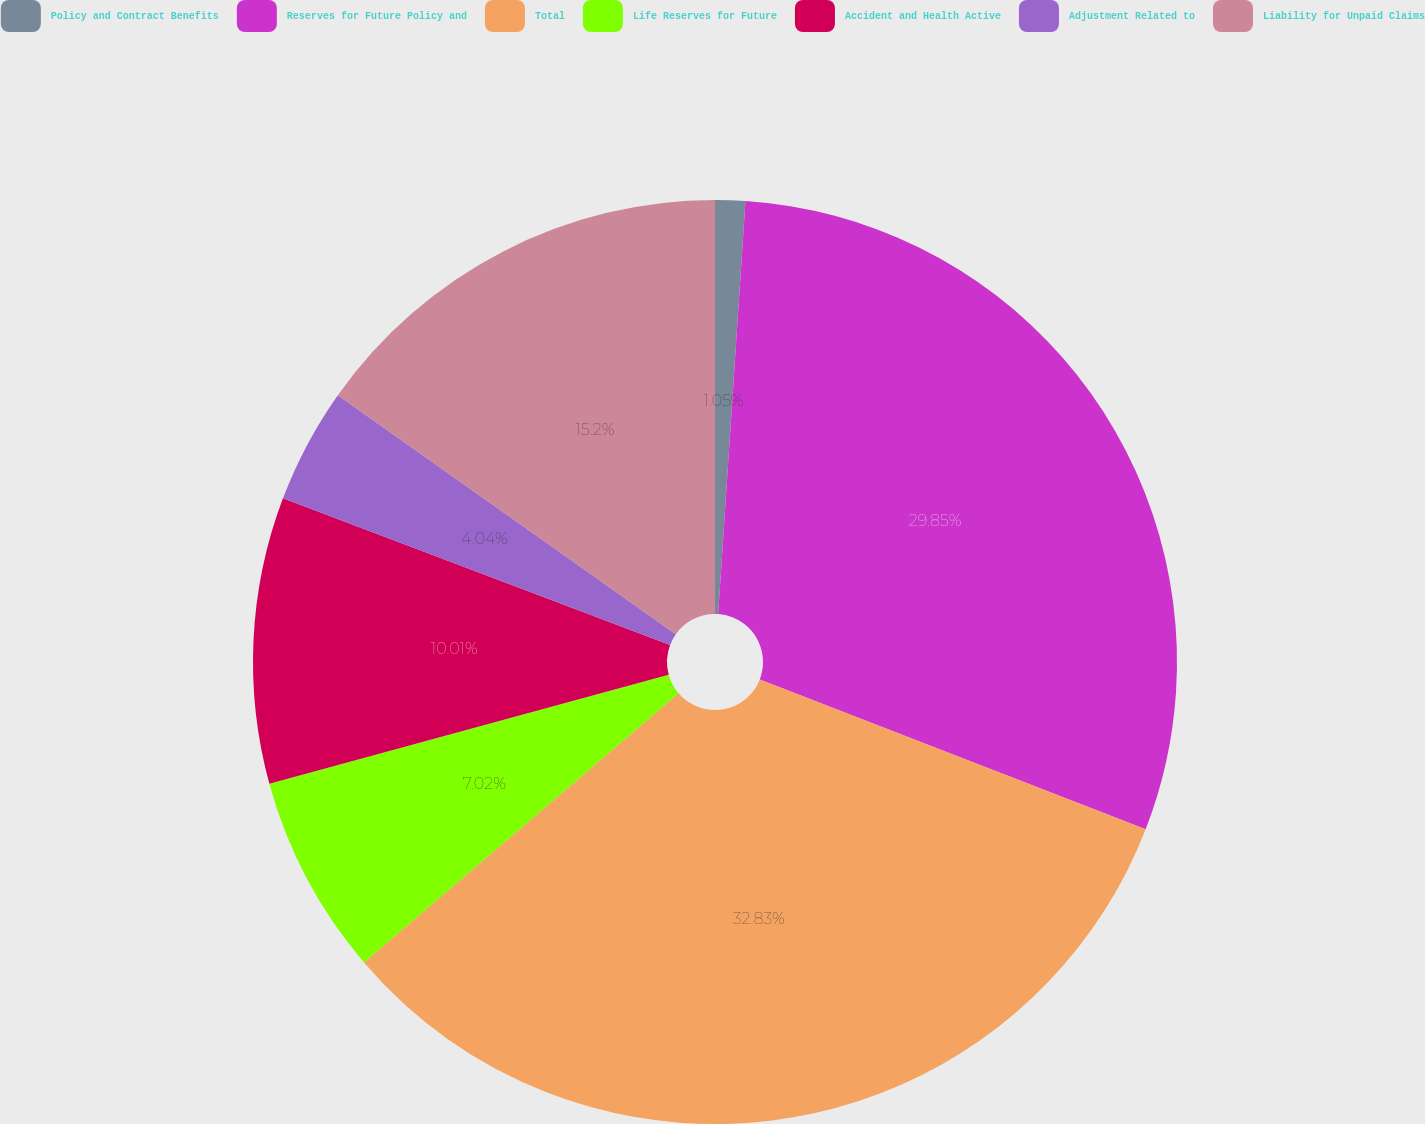Convert chart to OTSL. <chart><loc_0><loc_0><loc_500><loc_500><pie_chart><fcel>Policy and Contract Benefits<fcel>Reserves for Future Policy and<fcel>Total<fcel>Life Reserves for Future<fcel>Accident and Health Active<fcel>Adjustment Related to<fcel>Liability for Unpaid Claims<nl><fcel>1.05%<fcel>29.85%<fcel>32.84%<fcel>7.02%<fcel>10.01%<fcel>4.04%<fcel>15.2%<nl></chart> 